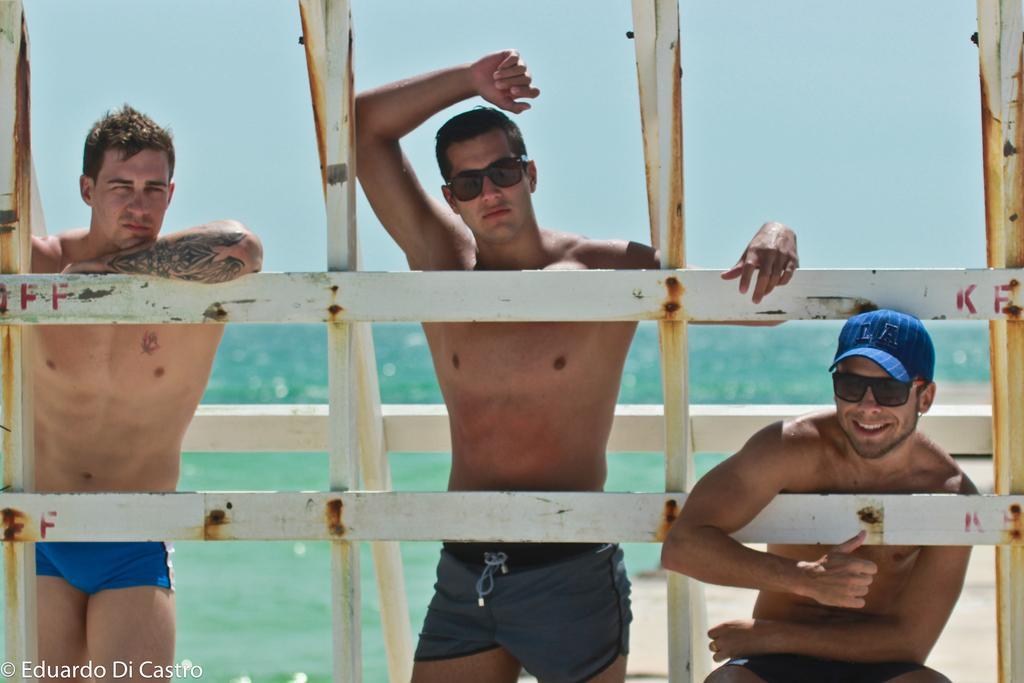Could you give a brief overview of what you see in this image? There are two men standing and a person sitting and smiling. This looks like a wooden fence. In the background, I think these are the water. At the bottom of the image, I can see the watermark. 